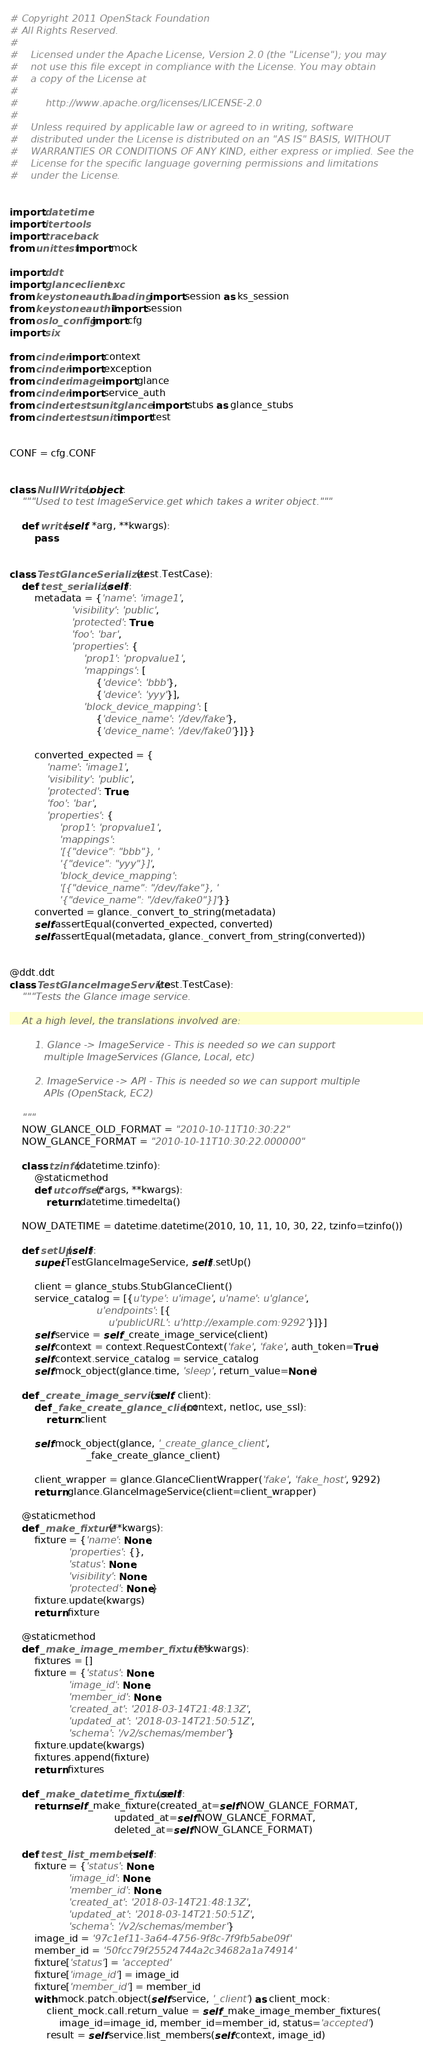<code> <loc_0><loc_0><loc_500><loc_500><_Python_># Copyright 2011 OpenStack Foundation
# All Rights Reserved.
#
#    Licensed under the Apache License, Version 2.0 (the "License"); you may
#    not use this file except in compliance with the License. You may obtain
#    a copy of the License at
#
#         http://www.apache.org/licenses/LICENSE-2.0
#
#    Unless required by applicable law or agreed to in writing, software
#    distributed under the License is distributed on an "AS IS" BASIS, WITHOUT
#    WARRANTIES OR CONDITIONS OF ANY KIND, either express or implied. See the
#    License for the specific language governing permissions and limitations
#    under the License.


import datetime
import itertools
import traceback
from unittest import mock

import ddt
import glanceclient.exc
from keystoneauth1.loading import session as ks_session
from keystoneauth1 import session
from oslo_config import cfg
import six

from cinder import context
from cinder import exception
from cinder.image import glance
from cinder import service_auth
from cinder.tests.unit.glance import stubs as glance_stubs
from cinder.tests.unit import test


CONF = cfg.CONF


class NullWriter(object):
    """Used to test ImageService.get which takes a writer object."""

    def write(self, *arg, **kwargs):
        pass


class TestGlanceSerializer(test.TestCase):
    def test_serialize(self):
        metadata = {'name': 'image1',
                    'visibility': 'public',
                    'protected': True,
                    'foo': 'bar',
                    'properties': {
                        'prop1': 'propvalue1',
                        'mappings': [
                            {'device': 'bbb'},
                            {'device': 'yyy'}],
                        'block_device_mapping': [
                            {'device_name': '/dev/fake'},
                            {'device_name': '/dev/fake0'}]}}

        converted_expected = {
            'name': 'image1',
            'visibility': 'public',
            'protected': True,
            'foo': 'bar',
            'properties': {
                'prop1': 'propvalue1',
                'mappings':
                '[{"device": "bbb"}, '
                '{"device": "yyy"}]',
                'block_device_mapping':
                '[{"device_name": "/dev/fake"}, '
                '{"device_name": "/dev/fake0"}]'}}
        converted = glance._convert_to_string(metadata)
        self.assertEqual(converted_expected, converted)
        self.assertEqual(metadata, glance._convert_from_string(converted))


@ddt.ddt
class TestGlanceImageService(test.TestCase):
    """Tests the Glance image service.

    At a high level, the translations involved are:

        1. Glance -> ImageService - This is needed so we can support
           multiple ImageServices (Glance, Local, etc)

        2. ImageService -> API - This is needed so we can support multiple
           APIs (OpenStack, EC2)

    """
    NOW_GLANCE_OLD_FORMAT = "2010-10-11T10:30:22"
    NOW_GLANCE_FORMAT = "2010-10-11T10:30:22.000000"

    class tzinfo(datetime.tzinfo):
        @staticmethod
        def utcoffset(*args, **kwargs):
            return datetime.timedelta()

    NOW_DATETIME = datetime.datetime(2010, 10, 11, 10, 30, 22, tzinfo=tzinfo())

    def setUp(self):
        super(TestGlanceImageService, self).setUp()

        client = glance_stubs.StubGlanceClient()
        service_catalog = [{u'type': u'image', u'name': u'glance',
                            u'endpoints': [{
                                u'publicURL': u'http://example.com:9292'}]}]
        self.service = self._create_image_service(client)
        self.context = context.RequestContext('fake', 'fake', auth_token=True)
        self.context.service_catalog = service_catalog
        self.mock_object(glance.time, 'sleep', return_value=None)

    def _create_image_service(self, client):
        def _fake_create_glance_client(context, netloc, use_ssl):
            return client

        self.mock_object(glance, '_create_glance_client',
                         _fake_create_glance_client)

        client_wrapper = glance.GlanceClientWrapper('fake', 'fake_host', 9292)
        return glance.GlanceImageService(client=client_wrapper)

    @staticmethod
    def _make_fixture(**kwargs):
        fixture = {'name': None,
                   'properties': {},
                   'status': None,
                   'visibility': None,
                   'protected': None}
        fixture.update(kwargs)
        return fixture

    @staticmethod
    def _make_image_member_fixtures(**kwargs):
        fixtures = []
        fixture = {'status': None,
                   'image_id': None,
                   'member_id': None,
                   'created_at': '2018-03-14T21:48:13Z',
                   'updated_at': '2018-03-14T21:50:51Z',
                   'schema': '/v2/schemas/member'}
        fixture.update(kwargs)
        fixtures.append(fixture)
        return fixtures

    def _make_datetime_fixture(self):
        return self._make_fixture(created_at=self.NOW_GLANCE_FORMAT,
                                  updated_at=self.NOW_GLANCE_FORMAT,
                                  deleted_at=self.NOW_GLANCE_FORMAT)

    def test_list_members(self):
        fixture = {'status': None,
                   'image_id': None,
                   'member_id': None,
                   'created_at': '2018-03-14T21:48:13Z',
                   'updated_at': '2018-03-14T21:50:51Z',
                   'schema': '/v2/schemas/member'}
        image_id = '97c1ef11-3a64-4756-9f8c-7f9fb5abe09f'
        member_id = '50fcc79f25524744a2c34682a1a74914'
        fixture['status'] = 'accepted'
        fixture['image_id'] = image_id
        fixture['member_id'] = member_id
        with mock.patch.object(self.service, '_client') as client_mock:
            client_mock.call.return_value = self._make_image_member_fixtures(
                image_id=image_id, member_id=member_id, status='accepted')
            result = self.service.list_members(self.context, image_id)</code> 